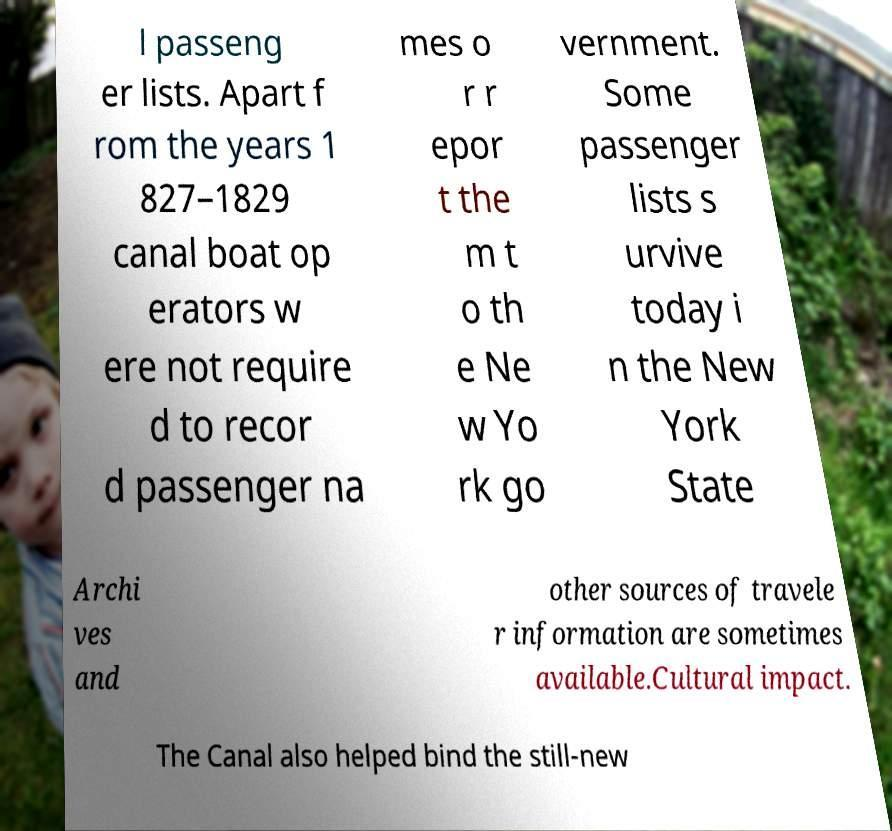There's text embedded in this image that I need extracted. Can you transcribe it verbatim? l passeng er lists. Apart f rom the years 1 827–1829 canal boat op erators w ere not require d to recor d passenger na mes o r r epor t the m t o th e Ne w Yo rk go vernment. Some passenger lists s urvive today i n the New York State Archi ves and other sources of travele r information are sometimes available.Cultural impact. The Canal also helped bind the still-new 